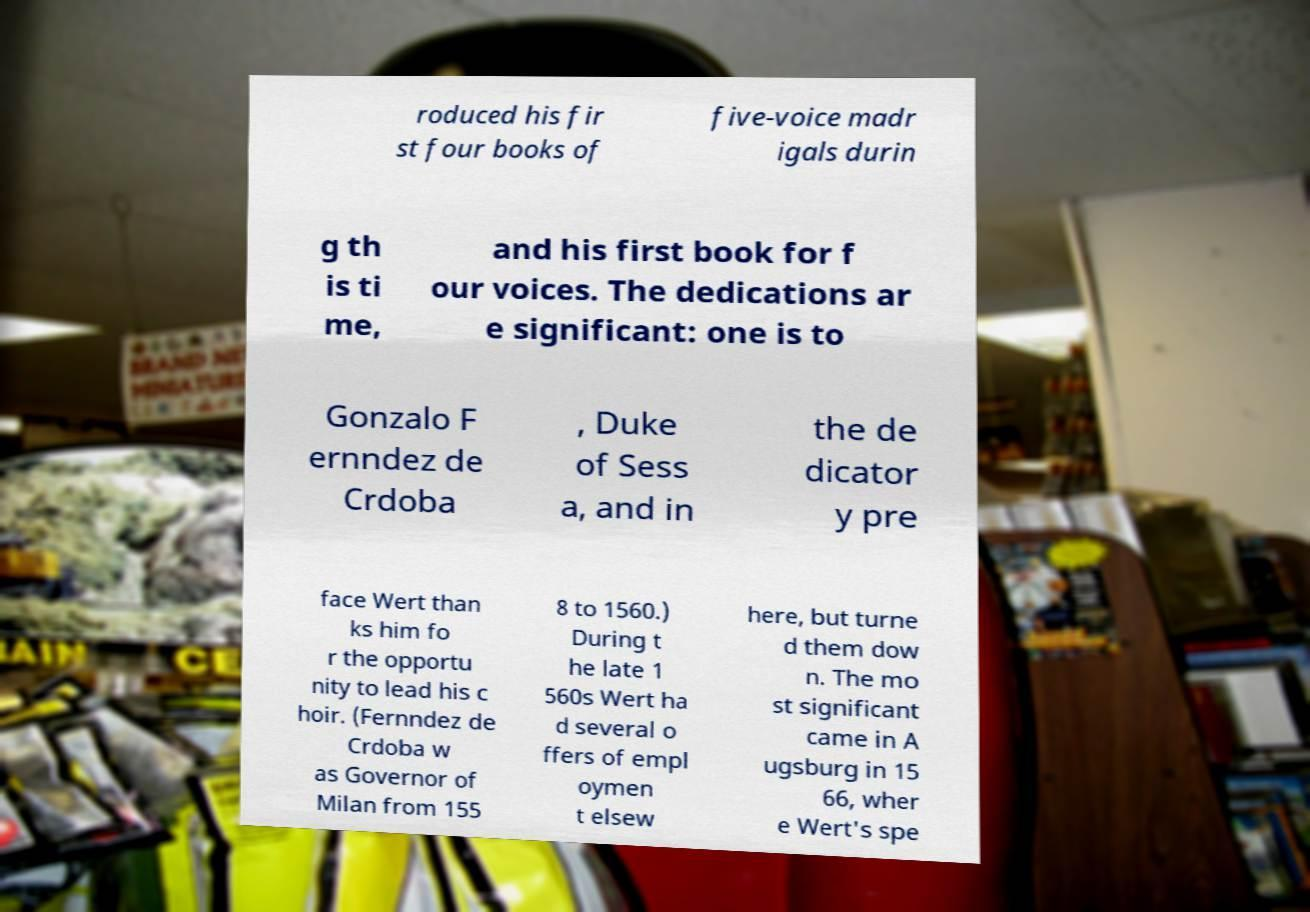Could you extract and type out the text from this image? roduced his fir st four books of five-voice madr igals durin g th is ti me, and his first book for f our voices. The dedications ar e significant: one is to Gonzalo F ernndez de Crdoba , Duke of Sess a, and in the de dicator y pre face Wert than ks him fo r the opportu nity to lead his c hoir. (Fernndez de Crdoba w as Governor of Milan from 155 8 to 1560.) During t he late 1 560s Wert ha d several o ffers of empl oymen t elsew here, but turne d them dow n. The mo st significant came in A ugsburg in 15 66, wher e Wert's spe 